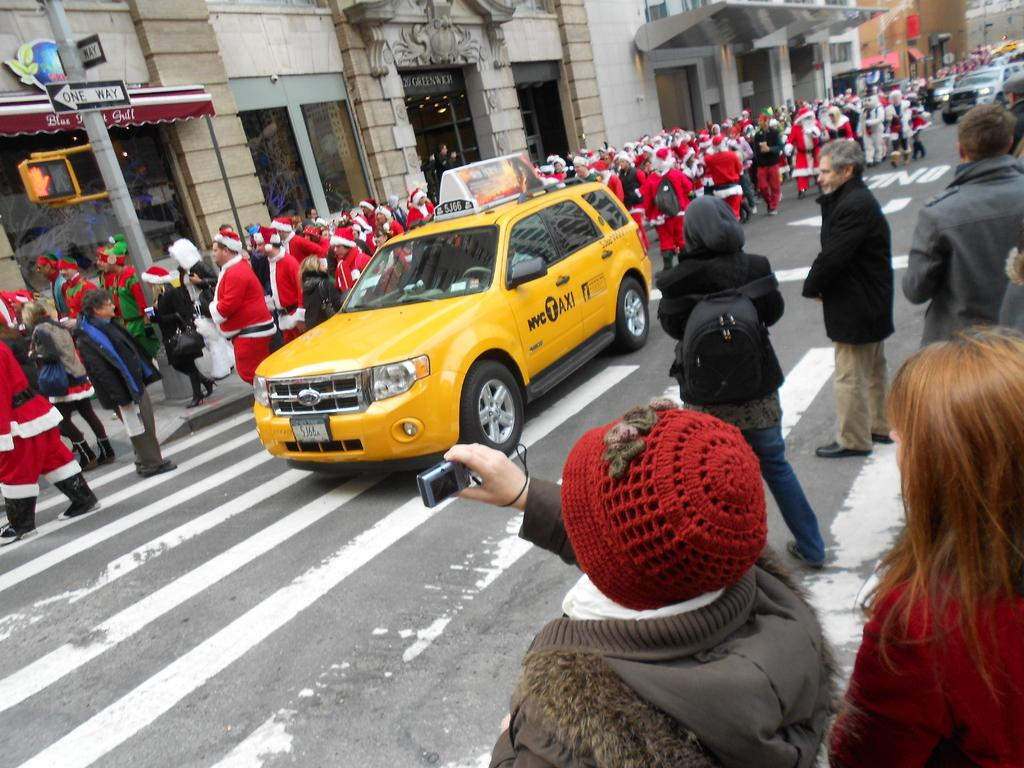<image>
Write a terse but informative summary of the picture. a busy street with a nyc taxi cab in the middle 